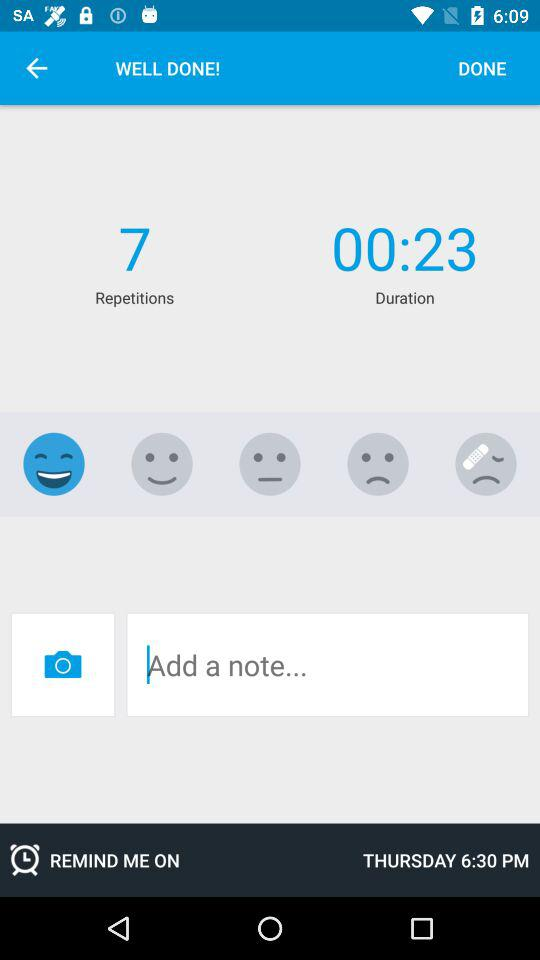What is the status of "REMIND ME"? The status is "on". 